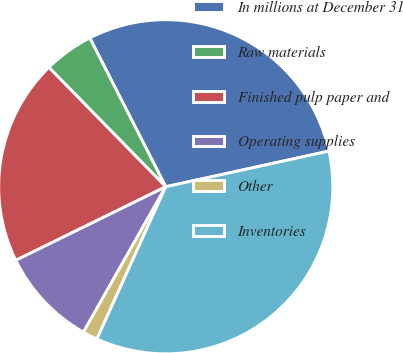Convert chart to OTSL. <chart><loc_0><loc_0><loc_500><loc_500><pie_chart><fcel>In millions at December 31<fcel>Raw materials<fcel>Finished pulp paper and<fcel>Operating supplies<fcel>Other<fcel>Inventories<nl><fcel>29.09%<fcel>4.82%<fcel>19.93%<fcel>9.54%<fcel>1.44%<fcel>35.18%<nl></chart> 